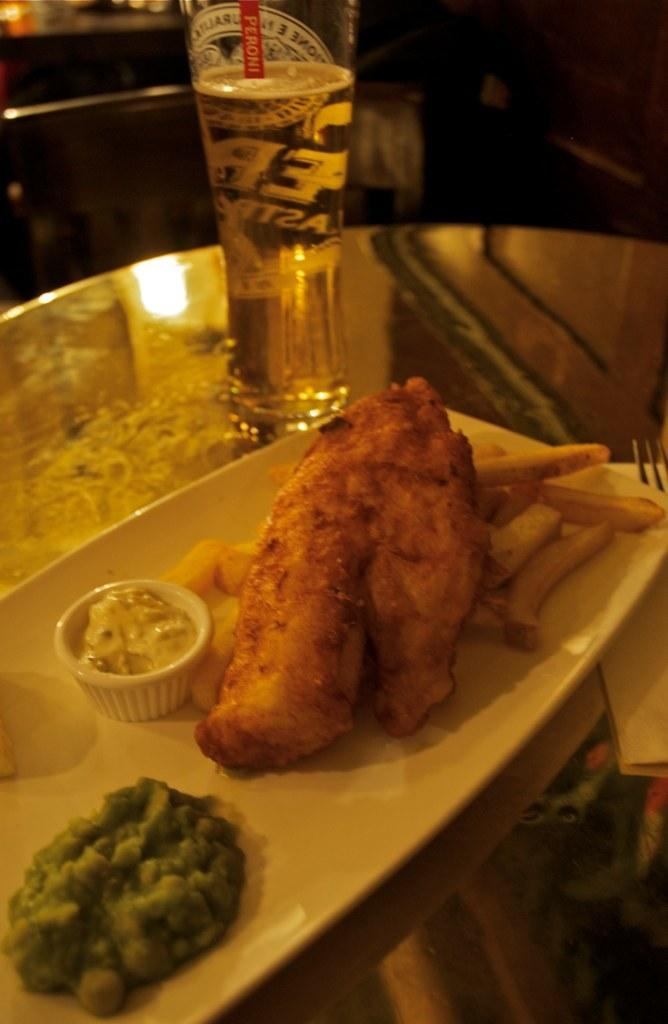<image>
Provide a brief description of the given image. The glass of beer on the table has a stir stick inside that reads Peroni. 